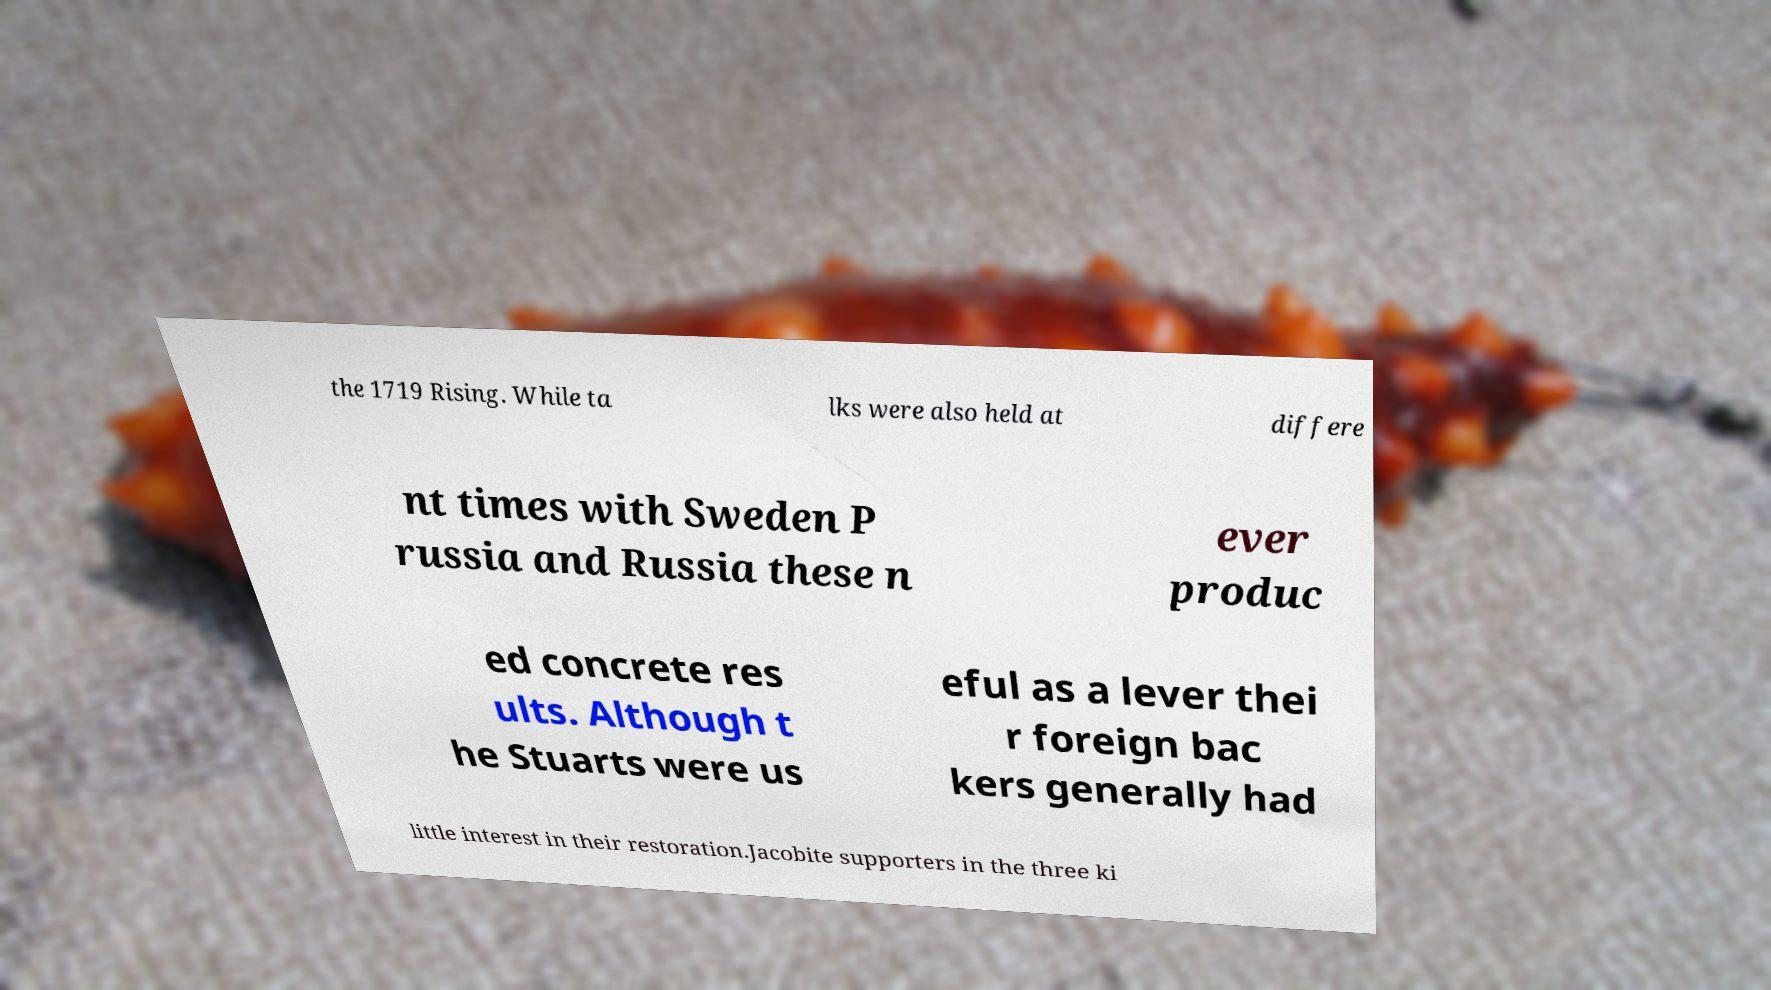I need the written content from this picture converted into text. Can you do that? the 1719 Rising. While ta lks were also held at differe nt times with Sweden P russia and Russia these n ever produc ed concrete res ults. Although t he Stuarts were us eful as a lever thei r foreign bac kers generally had little interest in their restoration.Jacobite supporters in the three ki 